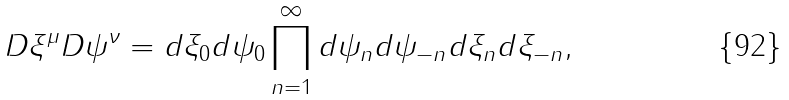Convert formula to latex. <formula><loc_0><loc_0><loc_500><loc_500>D \xi ^ { \mu } D \psi ^ { \nu } = d \xi _ { 0 } d \psi _ { 0 } \prod _ { n = 1 } ^ { \infty } d \psi _ { n } d \psi _ { - n } d \xi _ { n } d \xi _ { - n } ,</formula> 